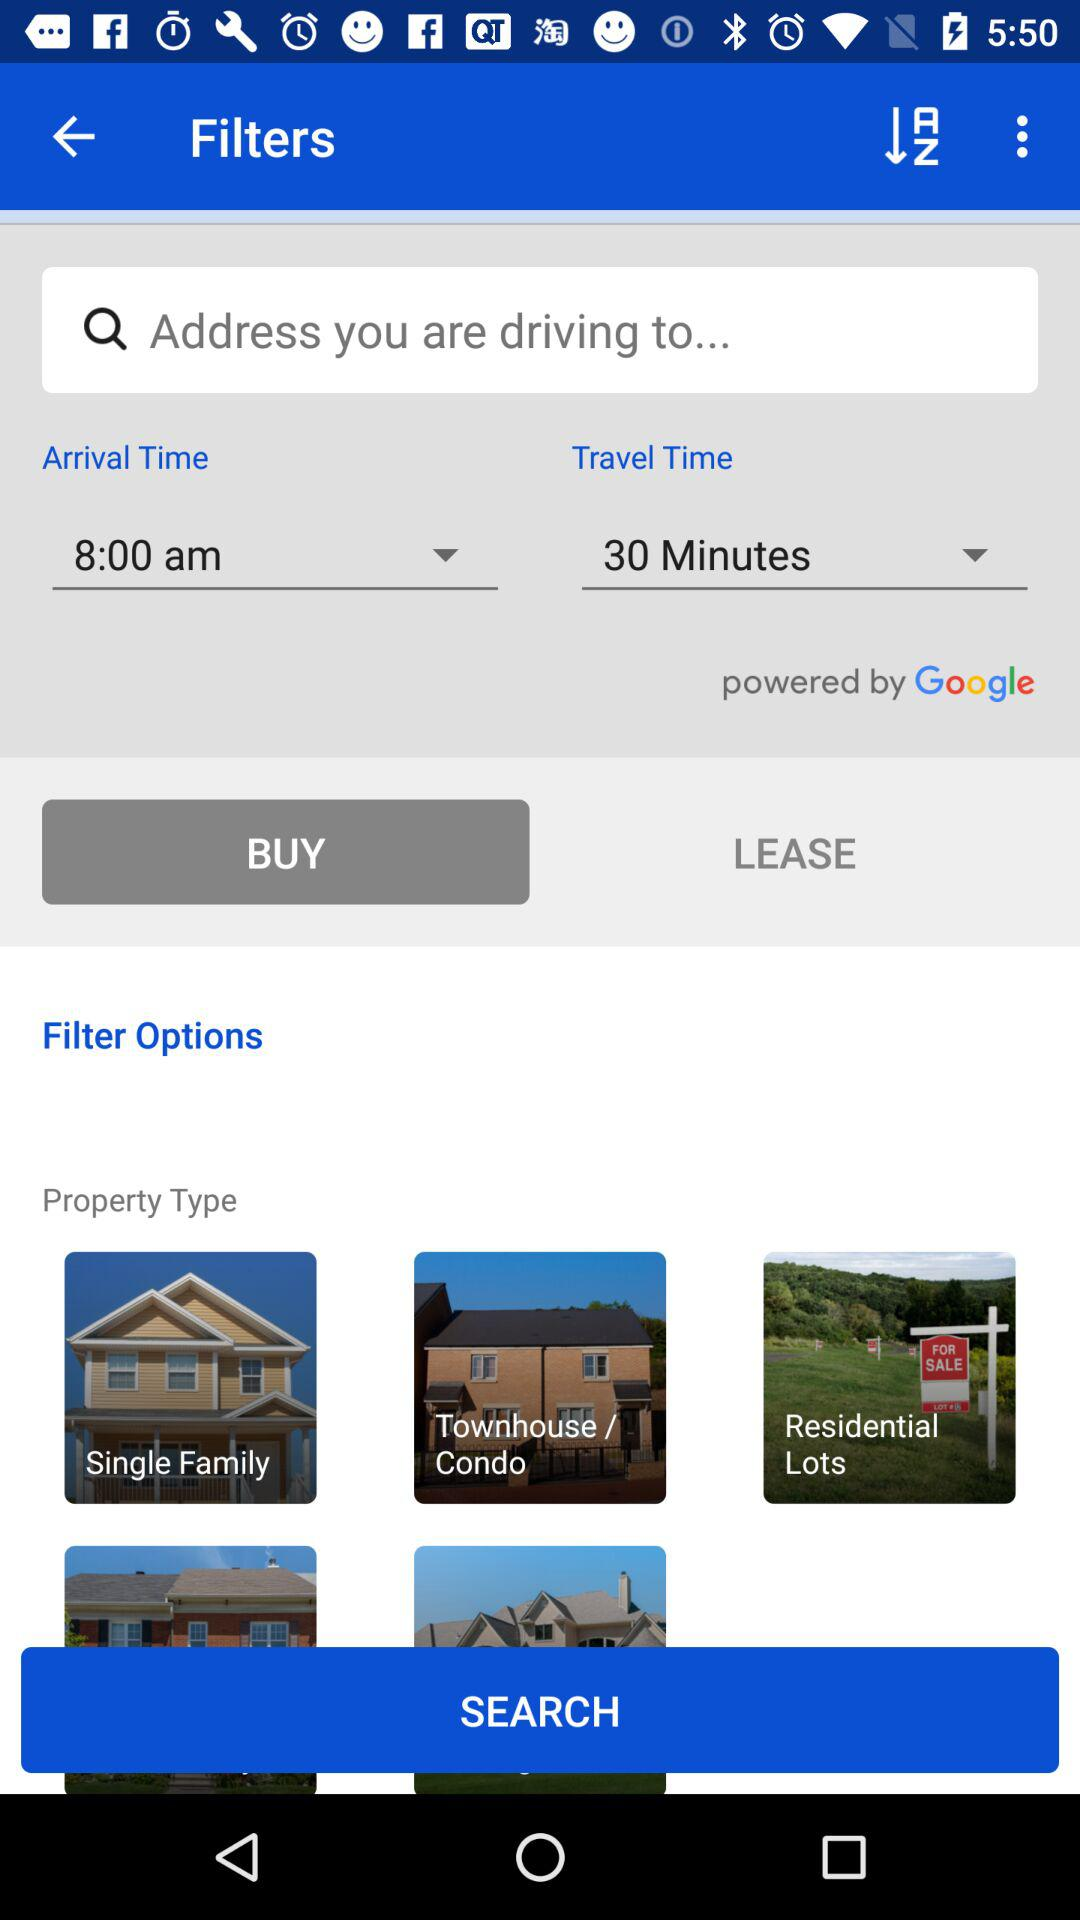What's the arrival time? The arrival time is 8:00 a.m. 